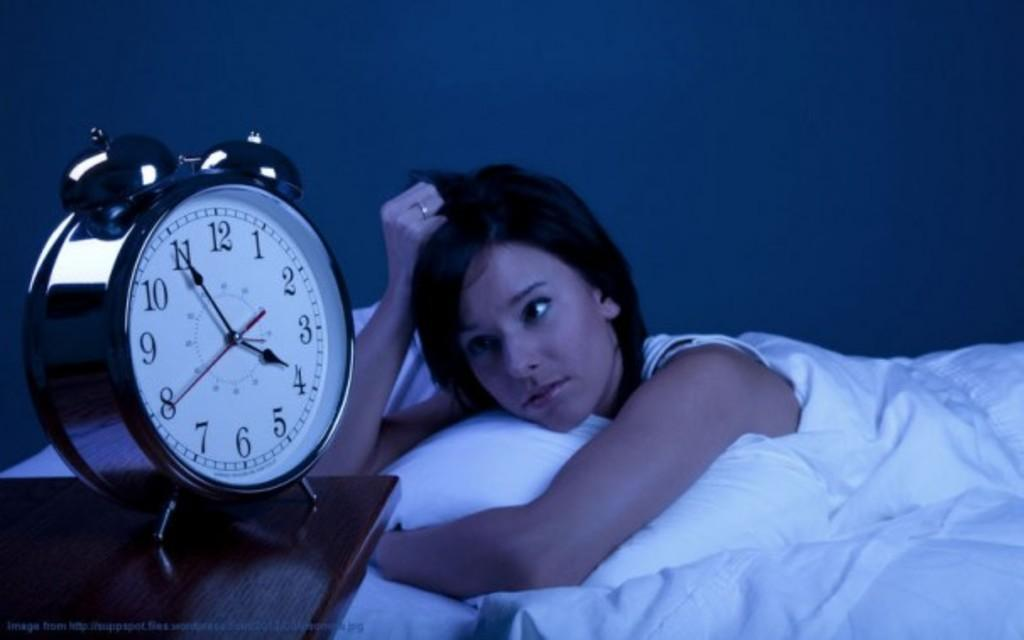<image>
Describe the image concisely. A woman looking exasperatedly at a clock reading 3:55 